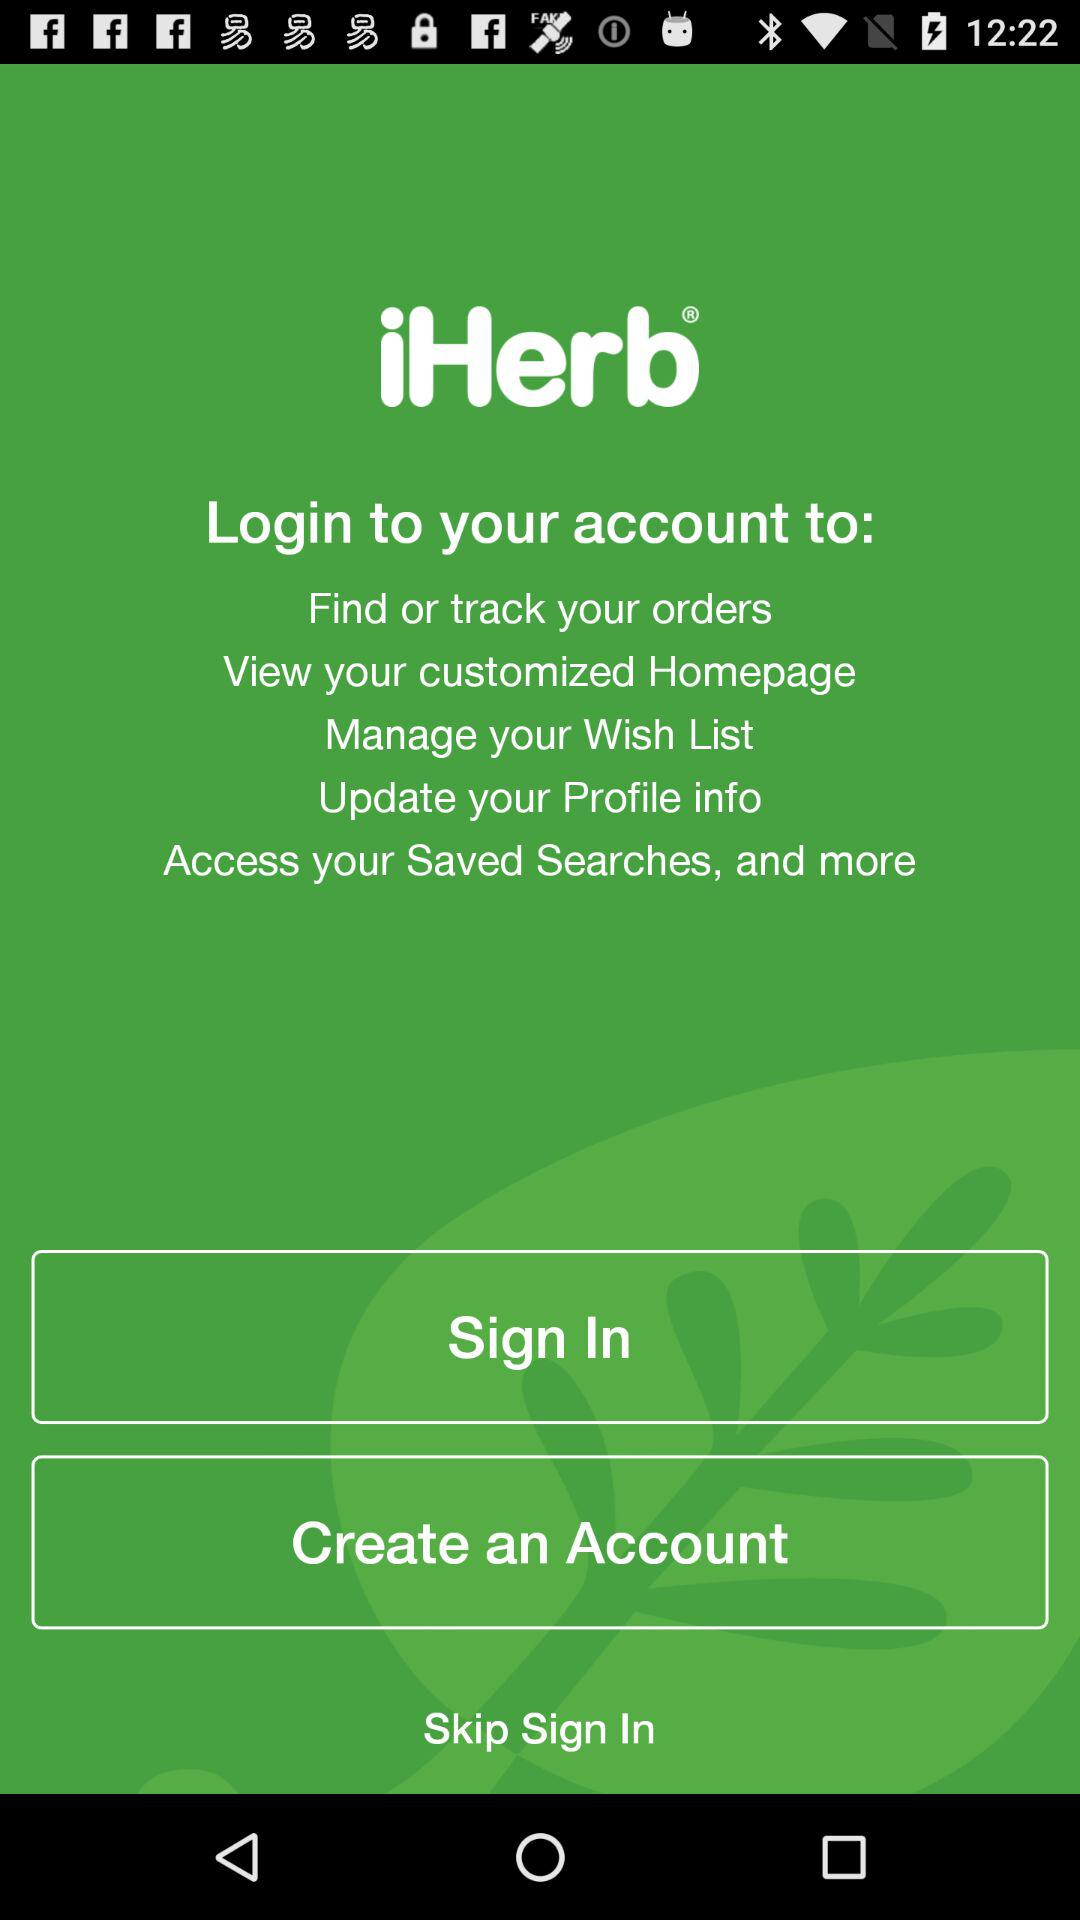What is the name of the application? The name of the application is "iHerb". 